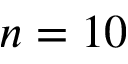<formula> <loc_0><loc_0><loc_500><loc_500>n = 1 0</formula> 